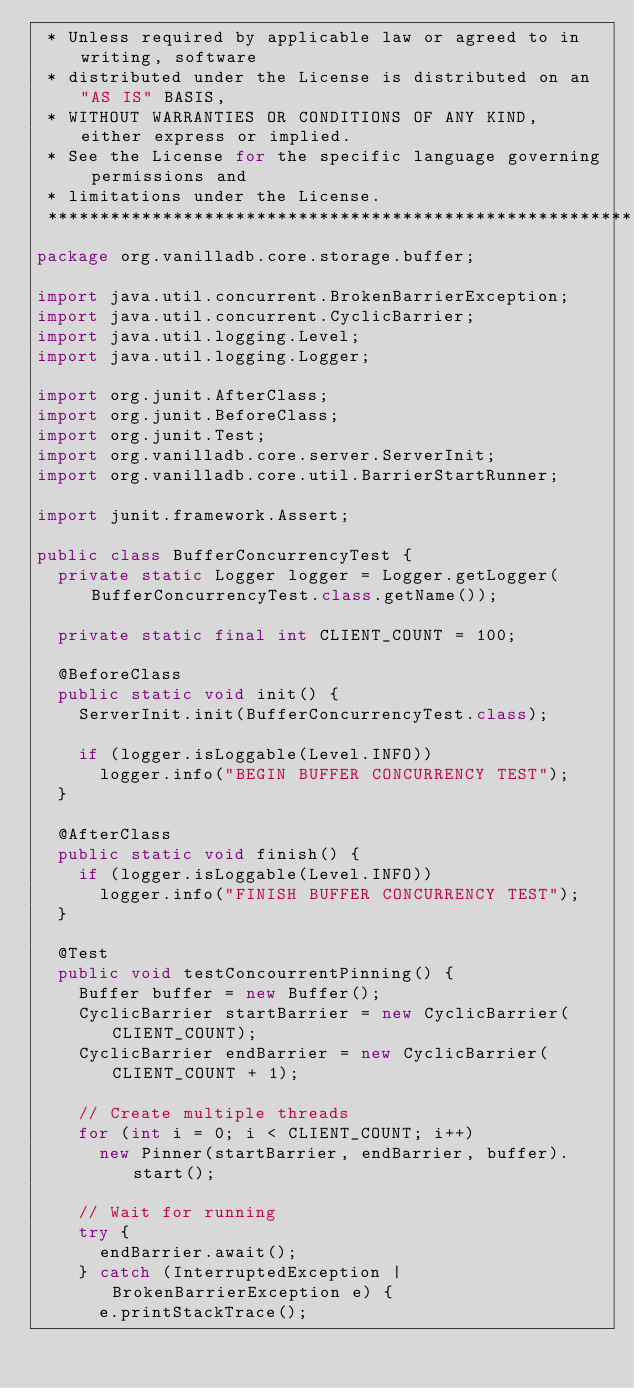<code> <loc_0><loc_0><loc_500><loc_500><_Java_> * Unless required by applicable law or agreed to in writing, software
 * distributed under the License is distributed on an "AS IS" BASIS,
 * WITHOUT WARRANTIES OR CONDITIONS OF ANY KIND, either express or implied.
 * See the License for the specific language governing permissions and
 * limitations under the License.
 *******************************************************************************/
package org.vanilladb.core.storage.buffer;

import java.util.concurrent.BrokenBarrierException;
import java.util.concurrent.CyclicBarrier;
import java.util.logging.Level;
import java.util.logging.Logger;

import org.junit.AfterClass;
import org.junit.BeforeClass;
import org.junit.Test;
import org.vanilladb.core.server.ServerInit;
import org.vanilladb.core.util.BarrierStartRunner;

import junit.framework.Assert;

public class BufferConcurrencyTest {
	private static Logger logger = Logger.getLogger(BufferConcurrencyTest.class.getName());

	private static final int CLIENT_COUNT = 100;

	@BeforeClass
	public static void init() {
		ServerInit.init(BufferConcurrencyTest.class);
		
		if (logger.isLoggable(Level.INFO))
			logger.info("BEGIN BUFFER CONCURRENCY TEST");
	}
	
	@AfterClass
	public static void finish() {
		if (logger.isLoggable(Level.INFO))
			logger.info("FINISH BUFFER CONCURRENCY TEST");
	}

	@Test
	public void testConcourrentPinning() {
		Buffer buffer = new Buffer();
		CyclicBarrier startBarrier = new CyclicBarrier(CLIENT_COUNT);
		CyclicBarrier endBarrier = new CyclicBarrier(CLIENT_COUNT + 1);

		// Create multiple threads
		for (int i = 0; i < CLIENT_COUNT; i++)
			new Pinner(startBarrier, endBarrier, buffer).start();

		// Wait for running
		try {
			endBarrier.await();
		} catch (InterruptedException | BrokenBarrierException e) {
			e.printStackTrace();</code> 